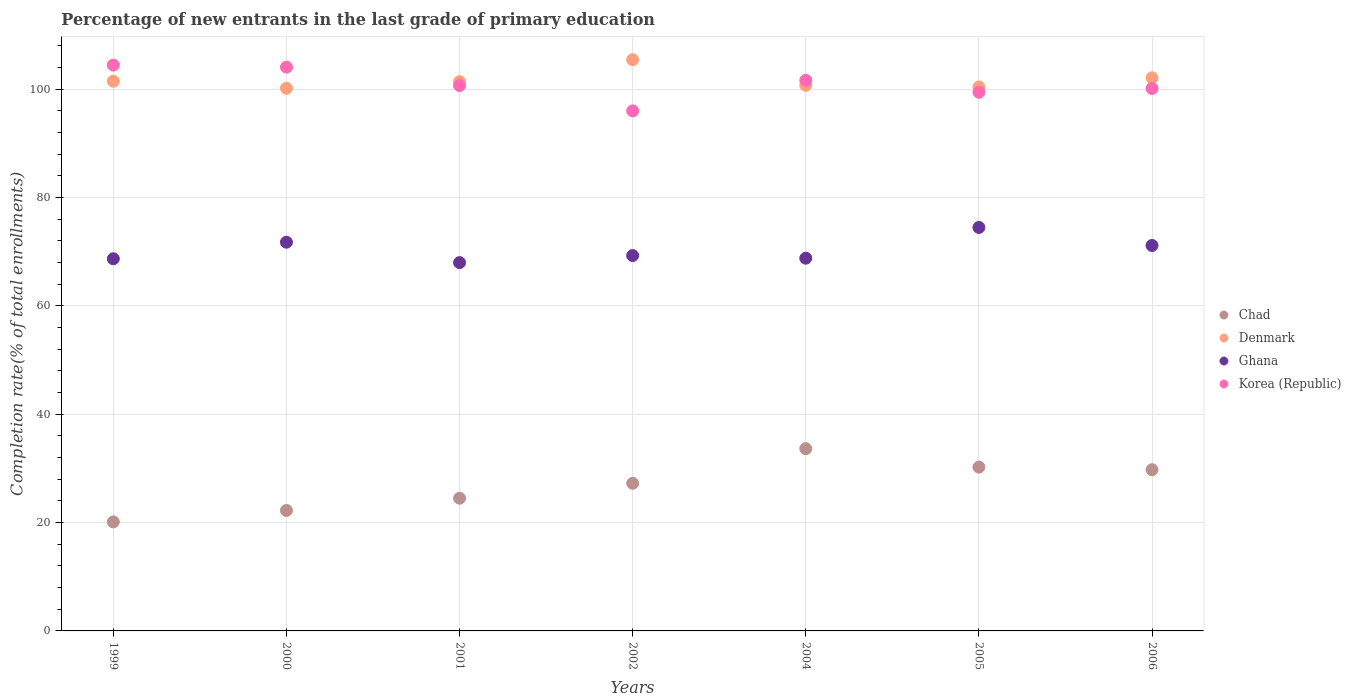How many different coloured dotlines are there?
Offer a very short reply. 4. What is the percentage of new entrants in Denmark in 2001?
Your response must be concise. 101.41. Across all years, what is the maximum percentage of new entrants in Ghana?
Keep it short and to the point. 74.5. Across all years, what is the minimum percentage of new entrants in Chad?
Keep it short and to the point. 20.13. What is the total percentage of new entrants in Korea (Republic) in the graph?
Make the answer very short. 706.56. What is the difference between the percentage of new entrants in Denmark in 2004 and that in 2006?
Make the answer very short. -1.38. What is the difference between the percentage of new entrants in Denmark in 2004 and the percentage of new entrants in Chad in 2005?
Ensure brevity in your answer.  70.51. What is the average percentage of new entrants in Chad per year?
Ensure brevity in your answer.  26.83. In the year 2004, what is the difference between the percentage of new entrants in Chad and percentage of new entrants in Korea (Republic)?
Give a very brief answer. -68.02. What is the ratio of the percentage of new entrants in Chad in 1999 to that in 2000?
Offer a terse response. 0.9. Is the percentage of new entrants in Chad in 1999 less than that in 2001?
Provide a succinct answer. Yes. What is the difference between the highest and the second highest percentage of new entrants in Korea (Republic)?
Offer a very short reply. 0.38. What is the difference between the highest and the lowest percentage of new entrants in Chad?
Offer a terse response. 13.52. In how many years, is the percentage of new entrants in Ghana greater than the average percentage of new entrants in Ghana taken over all years?
Keep it short and to the point. 3. Is it the case that in every year, the sum of the percentage of new entrants in Chad and percentage of new entrants in Korea (Republic)  is greater than the percentage of new entrants in Denmark?
Make the answer very short. Yes. Does the percentage of new entrants in Ghana monotonically increase over the years?
Offer a terse response. No. Is the percentage of new entrants in Chad strictly greater than the percentage of new entrants in Ghana over the years?
Your answer should be compact. No. How many years are there in the graph?
Offer a very short reply. 7. Are the values on the major ticks of Y-axis written in scientific E-notation?
Your answer should be very brief. No. Does the graph contain grids?
Give a very brief answer. Yes. How are the legend labels stacked?
Give a very brief answer. Vertical. What is the title of the graph?
Offer a very short reply. Percentage of new entrants in the last grade of primary education. Does "Italy" appear as one of the legend labels in the graph?
Provide a short and direct response. No. What is the label or title of the Y-axis?
Make the answer very short. Completion rate(% of total enrollments). What is the Completion rate(% of total enrollments) in Chad in 1999?
Make the answer very short. 20.13. What is the Completion rate(% of total enrollments) in Denmark in 1999?
Your response must be concise. 101.49. What is the Completion rate(% of total enrollments) in Ghana in 1999?
Ensure brevity in your answer.  68.71. What is the Completion rate(% of total enrollments) of Korea (Republic) in 1999?
Provide a short and direct response. 104.48. What is the Completion rate(% of total enrollments) of Chad in 2000?
Ensure brevity in your answer.  22.24. What is the Completion rate(% of total enrollments) in Denmark in 2000?
Provide a short and direct response. 100.19. What is the Completion rate(% of total enrollments) of Ghana in 2000?
Ensure brevity in your answer.  71.77. What is the Completion rate(% of total enrollments) of Korea (Republic) in 2000?
Provide a short and direct response. 104.1. What is the Completion rate(% of total enrollments) in Chad in 2001?
Ensure brevity in your answer.  24.5. What is the Completion rate(% of total enrollments) of Denmark in 2001?
Provide a short and direct response. 101.41. What is the Completion rate(% of total enrollments) in Ghana in 2001?
Keep it short and to the point. 68. What is the Completion rate(% of total enrollments) of Korea (Republic) in 2001?
Make the answer very short. 100.69. What is the Completion rate(% of total enrollments) of Chad in 2002?
Ensure brevity in your answer.  27.26. What is the Completion rate(% of total enrollments) in Denmark in 2002?
Offer a terse response. 105.47. What is the Completion rate(% of total enrollments) in Ghana in 2002?
Make the answer very short. 69.31. What is the Completion rate(% of total enrollments) of Korea (Republic) in 2002?
Provide a short and direct response. 96.02. What is the Completion rate(% of total enrollments) of Chad in 2004?
Offer a very short reply. 33.65. What is the Completion rate(% of total enrollments) of Denmark in 2004?
Your answer should be compact. 100.74. What is the Completion rate(% of total enrollments) of Ghana in 2004?
Give a very brief answer. 68.82. What is the Completion rate(% of total enrollments) in Korea (Republic) in 2004?
Your answer should be compact. 101.67. What is the Completion rate(% of total enrollments) in Chad in 2005?
Provide a short and direct response. 30.24. What is the Completion rate(% of total enrollments) of Denmark in 2005?
Your answer should be very brief. 100.45. What is the Completion rate(% of total enrollments) in Ghana in 2005?
Give a very brief answer. 74.5. What is the Completion rate(% of total enrollments) of Korea (Republic) in 2005?
Your answer should be very brief. 99.46. What is the Completion rate(% of total enrollments) of Chad in 2006?
Your answer should be very brief. 29.76. What is the Completion rate(% of total enrollments) in Denmark in 2006?
Ensure brevity in your answer.  102.13. What is the Completion rate(% of total enrollments) in Ghana in 2006?
Give a very brief answer. 71.17. What is the Completion rate(% of total enrollments) of Korea (Republic) in 2006?
Provide a short and direct response. 100.16. Across all years, what is the maximum Completion rate(% of total enrollments) of Chad?
Offer a very short reply. 33.65. Across all years, what is the maximum Completion rate(% of total enrollments) of Denmark?
Ensure brevity in your answer.  105.47. Across all years, what is the maximum Completion rate(% of total enrollments) of Ghana?
Your response must be concise. 74.5. Across all years, what is the maximum Completion rate(% of total enrollments) of Korea (Republic)?
Provide a succinct answer. 104.48. Across all years, what is the minimum Completion rate(% of total enrollments) of Chad?
Your answer should be very brief. 20.13. Across all years, what is the minimum Completion rate(% of total enrollments) of Denmark?
Your answer should be very brief. 100.19. Across all years, what is the minimum Completion rate(% of total enrollments) in Ghana?
Your answer should be very brief. 68. Across all years, what is the minimum Completion rate(% of total enrollments) of Korea (Republic)?
Your answer should be compact. 96.02. What is the total Completion rate(% of total enrollments) in Chad in the graph?
Provide a short and direct response. 187.79. What is the total Completion rate(% of total enrollments) of Denmark in the graph?
Your answer should be compact. 711.89. What is the total Completion rate(% of total enrollments) of Ghana in the graph?
Ensure brevity in your answer.  492.28. What is the total Completion rate(% of total enrollments) of Korea (Republic) in the graph?
Provide a succinct answer. 706.56. What is the difference between the Completion rate(% of total enrollments) in Chad in 1999 and that in 2000?
Offer a very short reply. -2.11. What is the difference between the Completion rate(% of total enrollments) of Denmark in 1999 and that in 2000?
Ensure brevity in your answer.  1.3. What is the difference between the Completion rate(% of total enrollments) of Ghana in 1999 and that in 2000?
Offer a very short reply. -3.06. What is the difference between the Completion rate(% of total enrollments) of Korea (Republic) in 1999 and that in 2000?
Provide a short and direct response. 0.38. What is the difference between the Completion rate(% of total enrollments) in Chad in 1999 and that in 2001?
Give a very brief answer. -4.37. What is the difference between the Completion rate(% of total enrollments) in Denmark in 1999 and that in 2001?
Offer a very short reply. 0.08. What is the difference between the Completion rate(% of total enrollments) in Ghana in 1999 and that in 2001?
Offer a terse response. 0.71. What is the difference between the Completion rate(% of total enrollments) of Korea (Republic) in 1999 and that in 2001?
Your answer should be compact. 3.79. What is the difference between the Completion rate(% of total enrollments) in Chad in 1999 and that in 2002?
Offer a very short reply. -7.13. What is the difference between the Completion rate(% of total enrollments) in Denmark in 1999 and that in 2002?
Offer a terse response. -3.98. What is the difference between the Completion rate(% of total enrollments) in Ghana in 1999 and that in 2002?
Your answer should be very brief. -0.6. What is the difference between the Completion rate(% of total enrollments) of Korea (Republic) in 1999 and that in 2002?
Keep it short and to the point. 8.45. What is the difference between the Completion rate(% of total enrollments) of Chad in 1999 and that in 2004?
Provide a short and direct response. -13.52. What is the difference between the Completion rate(% of total enrollments) in Denmark in 1999 and that in 2004?
Your answer should be very brief. 0.75. What is the difference between the Completion rate(% of total enrollments) of Ghana in 1999 and that in 2004?
Keep it short and to the point. -0.11. What is the difference between the Completion rate(% of total enrollments) of Korea (Republic) in 1999 and that in 2004?
Offer a very short reply. 2.81. What is the difference between the Completion rate(% of total enrollments) of Chad in 1999 and that in 2005?
Offer a terse response. -10.11. What is the difference between the Completion rate(% of total enrollments) in Denmark in 1999 and that in 2005?
Ensure brevity in your answer.  1.05. What is the difference between the Completion rate(% of total enrollments) in Ghana in 1999 and that in 2005?
Keep it short and to the point. -5.78. What is the difference between the Completion rate(% of total enrollments) of Korea (Republic) in 1999 and that in 2005?
Ensure brevity in your answer.  5.02. What is the difference between the Completion rate(% of total enrollments) in Chad in 1999 and that in 2006?
Offer a terse response. -9.63. What is the difference between the Completion rate(% of total enrollments) of Denmark in 1999 and that in 2006?
Provide a succinct answer. -0.63. What is the difference between the Completion rate(% of total enrollments) in Ghana in 1999 and that in 2006?
Give a very brief answer. -2.46. What is the difference between the Completion rate(% of total enrollments) in Korea (Republic) in 1999 and that in 2006?
Your response must be concise. 4.32. What is the difference between the Completion rate(% of total enrollments) of Chad in 2000 and that in 2001?
Ensure brevity in your answer.  -2.26. What is the difference between the Completion rate(% of total enrollments) in Denmark in 2000 and that in 2001?
Offer a terse response. -1.22. What is the difference between the Completion rate(% of total enrollments) of Ghana in 2000 and that in 2001?
Provide a succinct answer. 3.77. What is the difference between the Completion rate(% of total enrollments) of Korea (Republic) in 2000 and that in 2001?
Offer a terse response. 3.41. What is the difference between the Completion rate(% of total enrollments) of Chad in 2000 and that in 2002?
Offer a very short reply. -5.02. What is the difference between the Completion rate(% of total enrollments) of Denmark in 2000 and that in 2002?
Your answer should be very brief. -5.28. What is the difference between the Completion rate(% of total enrollments) in Ghana in 2000 and that in 2002?
Make the answer very short. 2.46. What is the difference between the Completion rate(% of total enrollments) in Korea (Republic) in 2000 and that in 2002?
Your answer should be compact. 8.07. What is the difference between the Completion rate(% of total enrollments) in Chad in 2000 and that in 2004?
Your response must be concise. -11.4. What is the difference between the Completion rate(% of total enrollments) in Denmark in 2000 and that in 2004?
Provide a short and direct response. -0.55. What is the difference between the Completion rate(% of total enrollments) in Ghana in 2000 and that in 2004?
Offer a very short reply. 2.95. What is the difference between the Completion rate(% of total enrollments) of Korea (Republic) in 2000 and that in 2004?
Give a very brief answer. 2.43. What is the difference between the Completion rate(% of total enrollments) of Chad in 2000 and that in 2005?
Make the answer very short. -7.99. What is the difference between the Completion rate(% of total enrollments) of Denmark in 2000 and that in 2005?
Keep it short and to the point. -0.25. What is the difference between the Completion rate(% of total enrollments) in Ghana in 2000 and that in 2005?
Provide a succinct answer. -2.72. What is the difference between the Completion rate(% of total enrollments) in Korea (Republic) in 2000 and that in 2005?
Offer a terse response. 4.64. What is the difference between the Completion rate(% of total enrollments) in Chad in 2000 and that in 2006?
Offer a very short reply. -7.52. What is the difference between the Completion rate(% of total enrollments) in Denmark in 2000 and that in 2006?
Ensure brevity in your answer.  -1.93. What is the difference between the Completion rate(% of total enrollments) of Ghana in 2000 and that in 2006?
Make the answer very short. 0.6. What is the difference between the Completion rate(% of total enrollments) of Korea (Republic) in 2000 and that in 2006?
Provide a short and direct response. 3.94. What is the difference between the Completion rate(% of total enrollments) in Chad in 2001 and that in 2002?
Your answer should be very brief. -2.76. What is the difference between the Completion rate(% of total enrollments) of Denmark in 2001 and that in 2002?
Make the answer very short. -4.06. What is the difference between the Completion rate(% of total enrollments) in Ghana in 2001 and that in 2002?
Make the answer very short. -1.31. What is the difference between the Completion rate(% of total enrollments) of Korea (Republic) in 2001 and that in 2002?
Provide a succinct answer. 4.67. What is the difference between the Completion rate(% of total enrollments) in Chad in 2001 and that in 2004?
Make the answer very short. -9.14. What is the difference between the Completion rate(% of total enrollments) of Denmark in 2001 and that in 2004?
Give a very brief answer. 0.67. What is the difference between the Completion rate(% of total enrollments) in Ghana in 2001 and that in 2004?
Your answer should be very brief. -0.82. What is the difference between the Completion rate(% of total enrollments) of Korea (Republic) in 2001 and that in 2004?
Give a very brief answer. -0.98. What is the difference between the Completion rate(% of total enrollments) in Chad in 2001 and that in 2005?
Provide a short and direct response. -5.73. What is the difference between the Completion rate(% of total enrollments) of Denmark in 2001 and that in 2005?
Your response must be concise. 0.97. What is the difference between the Completion rate(% of total enrollments) of Ghana in 2001 and that in 2005?
Offer a terse response. -6.49. What is the difference between the Completion rate(% of total enrollments) in Korea (Republic) in 2001 and that in 2005?
Your response must be concise. 1.23. What is the difference between the Completion rate(% of total enrollments) of Chad in 2001 and that in 2006?
Provide a short and direct response. -5.26. What is the difference between the Completion rate(% of total enrollments) of Denmark in 2001 and that in 2006?
Provide a short and direct response. -0.71. What is the difference between the Completion rate(% of total enrollments) of Ghana in 2001 and that in 2006?
Keep it short and to the point. -3.17. What is the difference between the Completion rate(% of total enrollments) of Korea (Republic) in 2001 and that in 2006?
Provide a succinct answer. 0.53. What is the difference between the Completion rate(% of total enrollments) in Chad in 2002 and that in 2004?
Provide a succinct answer. -6.38. What is the difference between the Completion rate(% of total enrollments) in Denmark in 2002 and that in 2004?
Offer a terse response. 4.73. What is the difference between the Completion rate(% of total enrollments) in Ghana in 2002 and that in 2004?
Provide a short and direct response. 0.49. What is the difference between the Completion rate(% of total enrollments) in Korea (Republic) in 2002 and that in 2004?
Provide a succinct answer. -5.64. What is the difference between the Completion rate(% of total enrollments) of Chad in 2002 and that in 2005?
Offer a very short reply. -2.97. What is the difference between the Completion rate(% of total enrollments) in Denmark in 2002 and that in 2005?
Your answer should be compact. 5.02. What is the difference between the Completion rate(% of total enrollments) of Ghana in 2002 and that in 2005?
Give a very brief answer. -5.19. What is the difference between the Completion rate(% of total enrollments) of Korea (Republic) in 2002 and that in 2005?
Offer a terse response. -3.43. What is the difference between the Completion rate(% of total enrollments) of Chad in 2002 and that in 2006?
Make the answer very short. -2.5. What is the difference between the Completion rate(% of total enrollments) of Denmark in 2002 and that in 2006?
Make the answer very short. 3.35. What is the difference between the Completion rate(% of total enrollments) in Ghana in 2002 and that in 2006?
Offer a terse response. -1.86. What is the difference between the Completion rate(% of total enrollments) in Korea (Republic) in 2002 and that in 2006?
Your answer should be very brief. -4.14. What is the difference between the Completion rate(% of total enrollments) in Chad in 2004 and that in 2005?
Offer a terse response. 3.41. What is the difference between the Completion rate(% of total enrollments) of Denmark in 2004 and that in 2005?
Make the answer very short. 0.29. What is the difference between the Completion rate(% of total enrollments) in Ghana in 2004 and that in 2005?
Provide a succinct answer. -5.68. What is the difference between the Completion rate(% of total enrollments) in Korea (Republic) in 2004 and that in 2005?
Your response must be concise. 2.21. What is the difference between the Completion rate(% of total enrollments) of Chad in 2004 and that in 2006?
Provide a succinct answer. 3.89. What is the difference between the Completion rate(% of total enrollments) in Denmark in 2004 and that in 2006?
Make the answer very short. -1.38. What is the difference between the Completion rate(% of total enrollments) of Ghana in 2004 and that in 2006?
Provide a short and direct response. -2.35. What is the difference between the Completion rate(% of total enrollments) of Korea (Republic) in 2004 and that in 2006?
Provide a succinct answer. 1.51. What is the difference between the Completion rate(% of total enrollments) in Chad in 2005 and that in 2006?
Keep it short and to the point. 0.47. What is the difference between the Completion rate(% of total enrollments) of Denmark in 2005 and that in 2006?
Your answer should be very brief. -1.68. What is the difference between the Completion rate(% of total enrollments) of Ghana in 2005 and that in 2006?
Offer a terse response. 3.33. What is the difference between the Completion rate(% of total enrollments) in Korea (Republic) in 2005 and that in 2006?
Provide a short and direct response. -0.7. What is the difference between the Completion rate(% of total enrollments) of Chad in 1999 and the Completion rate(% of total enrollments) of Denmark in 2000?
Make the answer very short. -80.06. What is the difference between the Completion rate(% of total enrollments) in Chad in 1999 and the Completion rate(% of total enrollments) in Ghana in 2000?
Provide a succinct answer. -51.64. What is the difference between the Completion rate(% of total enrollments) in Chad in 1999 and the Completion rate(% of total enrollments) in Korea (Republic) in 2000?
Your response must be concise. -83.97. What is the difference between the Completion rate(% of total enrollments) of Denmark in 1999 and the Completion rate(% of total enrollments) of Ghana in 2000?
Provide a short and direct response. 29.72. What is the difference between the Completion rate(% of total enrollments) in Denmark in 1999 and the Completion rate(% of total enrollments) in Korea (Republic) in 2000?
Give a very brief answer. -2.6. What is the difference between the Completion rate(% of total enrollments) in Ghana in 1999 and the Completion rate(% of total enrollments) in Korea (Republic) in 2000?
Provide a succinct answer. -35.38. What is the difference between the Completion rate(% of total enrollments) in Chad in 1999 and the Completion rate(% of total enrollments) in Denmark in 2001?
Keep it short and to the point. -81.28. What is the difference between the Completion rate(% of total enrollments) in Chad in 1999 and the Completion rate(% of total enrollments) in Ghana in 2001?
Offer a terse response. -47.87. What is the difference between the Completion rate(% of total enrollments) of Chad in 1999 and the Completion rate(% of total enrollments) of Korea (Republic) in 2001?
Ensure brevity in your answer.  -80.56. What is the difference between the Completion rate(% of total enrollments) of Denmark in 1999 and the Completion rate(% of total enrollments) of Ghana in 2001?
Offer a terse response. 33.49. What is the difference between the Completion rate(% of total enrollments) of Denmark in 1999 and the Completion rate(% of total enrollments) of Korea (Republic) in 2001?
Give a very brief answer. 0.8. What is the difference between the Completion rate(% of total enrollments) of Ghana in 1999 and the Completion rate(% of total enrollments) of Korea (Republic) in 2001?
Make the answer very short. -31.98. What is the difference between the Completion rate(% of total enrollments) of Chad in 1999 and the Completion rate(% of total enrollments) of Denmark in 2002?
Provide a short and direct response. -85.34. What is the difference between the Completion rate(% of total enrollments) in Chad in 1999 and the Completion rate(% of total enrollments) in Ghana in 2002?
Offer a terse response. -49.18. What is the difference between the Completion rate(% of total enrollments) of Chad in 1999 and the Completion rate(% of total enrollments) of Korea (Republic) in 2002?
Keep it short and to the point. -75.89. What is the difference between the Completion rate(% of total enrollments) of Denmark in 1999 and the Completion rate(% of total enrollments) of Ghana in 2002?
Your answer should be compact. 32.18. What is the difference between the Completion rate(% of total enrollments) of Denmark in 1999 and the Completion rate(% of total enrollments) of Korea (Republic) in 2002?
Make the answer very short. 5.47. What is the difference between the Completion rate(% of total enrollments) of Ghana in 1999 and the Completion rate(% of total enrollments) of Korea (Republic) in 2002?
Make the answer very short. -27.31. What is the difference between the Completion rate(% of total enrollments) in Chad in 1999 and the Completion rate(% of total enrollments) in Denmark in 2004?
Ensure brevity in your answer.  -80.61. What is the difference between the Completion rate(% of total enrollments) of Chad in 1999 and the Completion rate(% of total enrollments) of Ghana in 2004?
Your response must be concise. -48.69. What is the difference between the Completion rate(% of total enrollments) in Chad in 1999 and the Completion rate(% of total enrollments) in Korea (Republic) in 2004?
Provide a succinct answer. -81.54. What is the difference between the Completion rate(% of total enrollments) of Denmark in 1999 and the Completion rate(% of total enrollments) of Ghana in 2004?
Give a very brief answer. 32.67. What is the difference between the Completion rate(% of total enrollments) in Denmark in 1999 and the Completion rate(% of total enrollments) in Korea (Republic) in 2004?
Ensure brevity in your answer.  -0.17. What is the difference between the Completion rate(% of total enrollments) of Ghana in 1999 and the Completion rate(% of total enrollments) of Korea (Republic) in 2004?
Keep it short and to the point. -32.95. What is the difference between the Completion rate(% of total enrollments) in Chad in 1999 and the Completion rate(% of total enrollments) in Denmark in 2005?
Your answer should be compact. -80.32. What is the difference between the Completion rate(% of total enrollments) of Chad in 1999 and the Completion rate(% of total enrollments) of Ghana in 2005?
Offer a terse response. -54.37. What is the difference between the Completion rate(% of total enrollments) in Chad in 1999 and the Completion rate(% of total enrollments) in Korea (Republic) in 2005?
Your answer should be very brief. -79.33. What is the difference between the Completion rate(% of total enrollments) of Denmark in 1999 and the Completion rate(% of total enrollments) of Ghana in 2005?
Offer a terse response. 27. What is the difference between the Completion rate(% of total enrollments) in Denmark in 1999 and the Completion rate(% of total enrollments) in Korea (Republic) in 2005?
Give a very brief answer. 2.04. What is the difference between the Completion rate(% of total enrollments) of Ghana in 1999 and the Completion rate(% of total enrollments) of Korea (Republic) in 2005?
Provide a short and direct response. -30.74. What is the difference between the Completion rate(% of total enrollments) of Chad in 1999 and the Completion rate(% of total enrollments) of Denmark in 2006?
Your response must be concise. -82. What is the difference between the Completion rate(% of total enrollments) of Chad in 1999 and the Completion rate(% of total enrollments) of Ghana in 2006?
Provide a short and direct response. -51.04. What is the difference between the Completion rate(% of total enrollments) in Chad in 1999 and the Completion rate(% of total enrollments) in Korea (Republic) in 2006?
Ensure brevity in your answer.  -80.03. What is the difference between the Completion rate(% of total enrollments) in Denmark in 1999 and the Completion rate(% of total enrollments) in Ghana in 2006?
Provide a succinct answer. 30.33. What is the difference between the Completion rate(% of total enrollments) of Denmark in 1999 and the Completion rate(% of total enrollments) of Korea (Republic) in 2006?
Make the answer very short. 1.34. What is the difference between the Completion rate(% of total enrollments) in Ghana in 1999 and the Completion rate(% of total enrollments) in Korea (Republic) in 2006?
Offer a very short reply. -31.44. What is the difference between the Completion rate(% of total enrollments) in Chad in 2000 and the Completion rate(% of total enrollments) in Denmark in 2001?
Provide a succinct answer. -79.17. What is the difference between the Completion rate(% of total enrollments) in Chad in 2000 and the Completion rate(% of total enrollments) in Ghana in 2001?
Ensure brevity in your answer.  -45.76. What is the difference between the Completion rate(% of total enrollments) of Chad in 2000 and the Completion rate(% of total enrollments) of Korea (Republic) in 2001?
Ensure brevity in your answer.  -78.44. What is the difference between the Completion rate(% of total enrollments) of Denmark in 2000 and the Completion rate(% of total enrollments) of Ghana in 2001?
Your answer should be compact. 32.19. What is the difference between the Completion rate(% of total enrollments) in Denmark in 2000 and the Completion rate(% of total enrollments) in Korea (Republic) in 2001?
Your answer should be very brief. -0.49. What is the difference between the Completion rate(% of total enrollments) in Ghana in 2000 and the Completion rate(% of total enrollments) in Korea (Republic) in 2001?
Ensure brevity in your answer.  -28.92. What is the difference between the Completion rate(% of total enrollments) in Chad in 2000 and the Completion rate(% of total enrollments) in Denmark in 2002?
Give a very brief answer. -83.23. What is the difference between the Completion rate(% of total enrollments) of Chad in 2000 and the Completion rate(% of total enrollments) of Ghana in 2002?
Make the answer very short. -47.07. What is the difference between the Completion rate(% of total enrollments) of Chad in 2000 and the Completion rate(% of total enrollments) of Korea (Republic) in 2002?
Provide a succinct answer. -73.78. What is the difference between the Completion rate(% of total enrollments) in Denmark in 2000 and the Completion rate(% of total enrollments) in Ghana in 2002?
Offer a very short reply. 30.88. What is the difference between the Completion rate(% of total enrollments) in Denmark in 2000 and the Completion rate(% of total enrollments) in Korea (Republic) in 2002?
Offer a terse response. 4.17. What is the difference between the Completion rate(% of total enrollments) in Ghana in 2000 and the Completion rate(% of total enrollments) in Korea (Republic) in 2002?
Your answer should be compact. -24.25. What is the difference between the Completion rate(% of total enrollments) in Chad in 2000 and the Completion rate(% of total enrollments) in Denmark in 2004?
Keep it short and to the point. -78.5. What is the difference between the Completion rate(% of total enrollments) of Chad in 2000 and the Completion rate(% of total enrollments) of Ghana in 2004?
Your answer should be compact. -46.57. What is the difference between the Completion rate(% of total enrollments) of Chad in 2000 and the Completion rate(% of total enrollments) of Korea (Republic) in 2004?
Your answer should be very brief. -79.42. What is the difference between the Completion rate(% of total enrollments) of Denmark in 2000 and the Completion rate(% of total enrollments) of Ghana in 2004?
Keep it short and to the point. 31.37. What is the difference between the Completion rate(% of total enrollments) in Denmark in 2000 and the Completion rate(% of total enrollments) in Korea (Republic) in 2004?
Make the answer very short. -1.47. What is the difference between the Completion rate(% of total enrollments) in Ghana in 2000 and the Completion rate(% of total enrollments) in Korea (Republic) in 2004?
Make the answer very short. -29.89. What is the difference between the Completion rate(% of total enrollments) in Chad in 2000 and the Completion rate(% of total enrollments) in Denmark in 2005?
Provide a succinct answer. -78.2. What is the difference between the Completion rate(% of total enrollments) of Chad in 2000 and the Completion rate(% of total enrollments) of Ghana in 2005?
Keep it short and to the point. -52.25. What is the difference between the Completion rate(% of total enrollments) of Chad in 2000 and the Completion rate(% of total enrollments) of Korea (Republic) in 2005?
Provide a short and direct response. -77.21. What is the difference between the Completion rate(% of total enrollments) in Denmark in 2000 and the Completion rate(% of total enrollments) in Ghana in 2005?
Your answer should be very brief. 25.7. What is the difference between the Completion rate(% of total enrollments) in Denmark in 2000 and the Completion rate(% of total enrollments) in Korea (Republic) in 2005?
Provide a short and direct response. 0.74. What is the difference between the Completion rate(% of total enrollments) of Ghana in 2000 and the Completion rate(% of total enrollments) of Korea (Republic) in 2005?
Your answer should be compact. -27.68. What is the difference between the Completion rate(% of total enrollments) of Chad in 2000 and the Completion rate(% of total enrollments) of Denmark in 2006?
Your answer should be compact. -79.88. What is the difference between the Completion rate(% of total enrollments) in Chad in 2000 and the Completion rate(% of total enrollments) in Ghana in 2006?
Your response must be concise. -48.92. What is the difference between the Completion rate(% of total enrollments) of Chad in 2000 and the Completion rate(% of total enrollments) of Korea (Republic) in 2006?
Ensure brevity in your answer.  -77.91. What is the difference between the Completion rate(% of total enrollments) of Denmark in 2000 and the Completion rate(% of total enrollments) of Ghana in 2006?
Your response must be concise. 29.03. What is the difference between the Completion rate(% of total enrollments) of Denmark in 2000 and the Completion rate(% of total enrollments) of Korea (Republic) in 2006?
Your response must be concise. 0.04. What is the difference between the Completion rate(% of total enrollments) of Ghana in 2000 and the Completion rate(% of total enrollments) of Korea (Republic) in 2006?
Your answer should be compact. -28.38. What is the difference between the Completion rate(% of total enrollments) of Chad in 2001 and the Completion rate(% of total enrollments) of Denmark in 2002?
Provide a succinct answer. -80.97. What is the difference between the Completion rate(% of total enrollments) of Chad in 2001 and the Completion rate(% of total enrollments) of Ghana in 2002?
Ensure brevity in your answer.  -44.81. What is the difference between the Completion rate(% of total enrollments) of Chad in 2001 and the Completion rate(% of total enrollments) of Korea (Republic) in 2002?
Make the answer very short. -71.52. What is the difference between the Completion rate(% of total enrollments) of Denmark in 2001 and the Completion rate(% of total enrollments) of Ghana in 2002?
Offer a terse response. 32.1. What is the difference between the Completion rate(% of total enrollments) of Denmark in 2001 and the Completion rate(% of total enrollments) of Korea (Republic) in 2002?
Offer a very short reply. 5.39. What is the difference between the Completion rate(% of total enrollments) in Ghana in 2001 and the Completion rate(% of total enrollments) in Korea (Republic) in 2002?
Offer a terse response. -28.02. What is the difference between the Completion rate(% of total enrollments) in Chad in 2001 and the Completion rate(% of total enrollments) in Denmark in 2004?
Make the answer very short. -76.24. What is the difference between the Completion rate(% of total enrollments) in Chad in 2001 and the Completion rate(% of total enrollments) in Ghana in 2004?
Ensure brevity in your answer.  -44.32. What is the difference between the Completion rate(% of total enrollments) in Chad in 2001 and the Completion rate(% of total enrollments) in Korea (Republic) in 2004?
Offer a very short reply. -77.16. What is the difference between the Completion rate(% of total enrollments) in Denmark in 2001 and the Completion rate(% of total enrollments) in Ghana in 2004?
Offer a very short reply. 32.59. What is the difference between the Completion rate(% of total enrollments) of Denmark in 2001 and the Completion rate(% of total enrollments) of Korea (Republic) in 2004?
Your answer should be compact. -0.25. What is the difference between the Completion rate(% of total enrollments) of Ghana in 2001 and the Completion rate(% of total enrollments) of Korea (Republic) in 2004?
Keep it short and to the point. -33.66. What is the difference between the Completion rate(% of total enrollments) in Chad in 2001 and the Completion rate(% of total enrollments) in Denmark in 2005?
Make the answer very short. -75.95. What is the difference between the Completion rate(% of total enrollments) of Chad in 2001 and the Completion rate(% of total enrollments) of Ghana in 2005?
Your answer should be very brief. -49.99. What is the difference between the Completion rate(% of total enrollments) in Chad in 2001 and the Completion rate(% of total enrollments) in Korea (Republic) in 2005?
Make the answer very short. -74.95. What is the difference between the Completion rate(% of total enrollments) of Denmark in 2001 and the Completion rate(% of total enrollments) of Ghana in 2005?
Your answer should be very brief. 26.92. What is the difference between the Completion rate(% of total enrollments) of Denmark in 2001 and the Completion rate(% of total enrollments) of Korea (Republic) in 2005?
Give a very brief answer. 1.96. What is the difference between the Completion rate(% of total enrollments) in Ghana in 2001 and the Completion rate(% of total enrollments) in Korea (Republic) in 2005?
Give a very brief answer. -31.45. What is the difference between the Completion rate(% of total enrollments) of Chad in 2001 and the Completion rate(% of total enrollments) of Denmark in 2006?
Your response must be concise. -77.62. What is the difference between the Completion rate(% of total enrollments) in Chad in 2001 and the Completion rate(% of total enrollments) in Ghana in 2006?
Make the answer very short. -46.67. What is the difference between the Completion rate(% of total enrollments) in Chad in 2001 and the Completion rate(% of total enrollments) in Korea (Republic) in 2006?
Make the answer very short. -75.65. What is the difference between the Completion rate(% of total enrollments) in Denmark in 2001 and the Completion rate(% of total enrollments) in Ghana in 2006?
Your response must be concise. 30.25. What is the difference between the Completion rate(% of total enrollments) of Denmark in 2001 and the Completion rate(% of total enrollments) of Korea (Republic) in 2006?
Your answer should be very brief. 1.26. What is the difference between the Completion rate(% of total enrollments) of Ghana in 2001 and the Completion rate(% of total enrollments) of Korea (Republic) in 2006?
Provide a succinct answer. -32.16. What is the difference between the Completion rate(% of total enrollments) in Chad in 2002 and the Completion rate(% of total enrollments) in Denmark in 2004?
Provide a short and direct response. -73.48. What is the difference between the Completion rate(% of total enrollments) of Chad in 2002 and the Completion rate(% of total enrollments) of Ghana in 2004?
Provide a short and direct response. -41.56. What is the difference between the Completion rate(% of total enrollments) of Chad in 2002 and the Completion rate(% of total enrollments) of Korea (Republic) in 2004?
Your answer should be compact. -74.4. What is the difference between the Completion rate(% of total enrollments) of Denmark in 2002 and the Completion rate(% of total enrollments) of Ghana in 2004?
Your response must be concise. 36.65. What is the difference between the Completion rate(% of total enrollments) of Denmark in 2002 and the Completion rate(% of total enrollments) of Korea (Republic) in 2004?
Provide a succinct answer. 3.81. What is the difference between the Completion rate(% of total enrollments) of Ghana in 2002 and the Completion rate(% of total enrollments) of Korea (Republic) in 2004?
Give a very brief answer. -32.35. What is the difference between the Completion rate(% of total enrollments) in Chad in 2002 and the Completion rate(% of total enrollments) in Denmark in 2005?
Offer a very short reply. -73.19. What is the difference between the Completion rate(% of total enrollments) in Chad in 2002 and the Completion rate(% of total enrollments) in Ghana in 2005?
Give a very brief answer. -47.23. What is the difference between the Completion rate(% of total enrollments) in Chad in 2002 and the Completion rate(% of total enrollments) in Korea (Republic) in 2005?
Offer a very short reply. -72.19. What is the difference between the Completion rate(% of total enrollments) in Denmark in 2002 and the Completion rate(% of total enrollments) in Ghana in 2005?
Ensure brevity in your answer.  30.98. What is the difference between the Completion rate(% of total enrollments) in Denmark in 2002 and the Completion rate(% of total enrollments) in Korea (Republic) in 2005?
Your answer should be very brief. 6.02. What is the difference between the Completion rate(% of total enrollments) in Ghana in 2002 and the Completion rate(% of total enrollments) in Korea (Republic) in 2005?
Make the answer very short. -30.15. What is the difference between the Completion rate(% of total enrollments) of Chad in 2002 and the Completion rate(% of total enrollments) of Denmark in 2006?
Offer a terse response. -74.86. What is the difference between the Completion rate(% of total enrollments) of Chad in 2002 and the Completion rate(% of total enrollments) of Ghana in 2006?
Your answer should be compact. -43.91. What is the difference between the Completion rate(% of total enrollments) in Chad in 2002 and the Completion rate(% of total enrollments) in Korea (Republic) in 2006?
Provide a succinct answer. -72.89. What is the difference between the Completion rate(% of total enrollments) in Denmark in 2002 and the Completion rate(% of total enrollments) in Ghana in 2006?
Offer a terse response. 34.3. What is the difference between the Completion rate(% of total enrollments) of Denmark in 2002 and the Completion rate(% of total enrollments) of Korea (Republic) in 2006?
Offer a terse response. 5.32. What is the difference between the Completion rate(% of total enrollments) of Ghana in 2002 and the Completion rate(% of total enrollments) of Korea (Republic) in 2006?
Your answer should be compact. -30.85. What is the difference between the Completion rate(% of total enrollments) of Chad in 2004 and the Completion rate(% of total enrollments) of Denmark in 2005?
Make the answer very short. -66.8. What is the difference between the Completion rate(% of total enrollments) of Chad in 2004 and the Completion rate(% of total enrollments) of Ghana in 2005?
Your response must be concise. -40.85. What is the difference between the Completion rate(% of total enrollments) in Chad in 2004 and the Completion rate(% of total enrollments) in Korea (Republic) in 2005?
Make the answer very short. -65.81. What is the difference between the Completion rate(% of total enrollments) of Denmark in 2004 and the Completion rate(% of total enrollments) of Ghana in 2005?
Provide a short and direct response. 26.25. What is the difference between the Completion rate(% of total enrollments) of Denmark in 2004 and the Completion rate(% of total enrollments) of Korea (Republic) in 2005?
Keep it short and to the point. 1.29. What is the difference between the Completion rate(% of total enrollments) of Ghana in 2004 and the Completion rate(% of total enrollments) of Korea (Republic) in 2005?
Keep it short and to the point. -30.64. What is the difference between the Completion rate(% of total enrollments) of Chad in 2004 and the Completion rate(% of total enrollments) of Denmark in 2006?
Your response must be concise. -68.48. What is the difference between the Completion rate(% of total enrollments) of Chad in 2004 and the Completion rate(% of total enrollments) of Ghana in 2006?
Offer a terse response. -37.52. What is the difference between the Completion rate(% of total enrollments) of Chad in 2004 and the Completion rate(% of total enrollments) of Korea (Republic) in 2006?
Give a very brief answer. -66.51. What is the difference between the Completion rate(% of total enrollments) of Denmark in 2004 and the Completion rate(% of total enrollments) of Ghana in 2006?
Make the answer very short. 29.57. What is the difference between the Completion rate(% of total enrollments) of Denmark in 2004 and the Completion rate(% of total enrollments) of Korea (Republic) in 2006?
Your answer should be compact. 0.58. What is the difference between the Completion rate(% of total enrollments) of Ghana in 2004 and the Completion rate(% of total enrollments) of Korea (Republic) in 2006?
Offer a terse response. -31.34. What is the difference between the Completion rate(% of total enrollments) in Chad in 2005 and the Completion rate(% of total enrollments) in Denmark in 2006?
Make the answer very short. -71.89. What is the difference between the Completion rate(% of total enrollments) in Chad in 2005 and the Completion rate(% of total enrollments) in Ghana in 2006?
Offer a terse response. -40.93. What is the difference between the Completion rate(% of total enrollments) of Chad in 2005 and the Completion rate(% of total enrollments) of Korea (Republic) in 2006?
Your response must be concise. -69.92. What is the difference between the Completion rate(% of total enrollments) in Denmark in 2005 and the Completion rate(% of total enrollments) in Ghana in 2006?
Keep it short and to the point. 29.28. What is the difference between the Completion rate(% of total enrollments) of Denmark in 2005 and the Completion rate(% of total enrollments) of Korea (Republic) in 2006?
Give a very brief answer. 0.29. What is the difference between the Completion rate(% of total enrollments) of Ghana in 2005 and the Completion rate(% of total enrollments) of Korea (Republic) in 2006?
Give a very brief answer. -25.66. What is the average Completion rate(% of total enrollments) of Chad per year?
Your answer should be very brief. 26.83. What is the average Completion rate(% of total enrollments) of Denmark per year?
Keep it short and to the point. 101.7. What is the average Completion rate(% of total enrollments) of Ghana per year?
Offer a very short reply. 70.33. What is the average Completion rate(% of total enrollments) in Korea (Republic) per year?
Keep it short and to the point. 100.94. In the year 1999, what is the difference between the Completion rate(% of total enrollments) in Chad and Completion rate(% of total enrollments) in Denmark?
Offer a very short reply. -81.36. In the year 1999, what is the difference between the Completion rate(% of total enrollments) in Chad and Completion rate(% of total enrollments) in Ghana?
Offer a very short reply. -48.58. In the year 1999, what is the difference between the Completion rate(% of total enrollments) in Chad and Completion rate(% of total enrollments) in Korea (Republic)?
Give a very brief answer. -84.35. In the year 1999, what is the difference between the Completion rate(% of total enrollments) in Denmark and Completion rate(% of total enrollments) in Ghana?
Your response must be concise. 32.78. In the year 1999, what is the difference between the Completion rate(% of total enrollments) in Denmark and Completion rate(% of total enrollments) in Korea (Republic)?
Keep it short and to the point. -2.98. In the year 1999, what is the difference between the Completion rate(% of total enrollments) of Ghana and Completion rate(% of total enrollments) of Korea (Republic)?
Your answer should be very brief. -35.76. In the year 2000, what is the difference between the Completion rate(% of total enrollments) in Chad and Completion rate(% of total enrollments) in Denmark?
Provide a succinct answer. -77.95. In the year 2000, what is the difference between the Completion rate(% of total enrollments) of Chad and Completion rate(% of total enrollments) of Ghana?
Offer a very short reply. -49.53. In the year 2000, what is the difference between the Completion rate(% of total enrollments) of Chad and Completion rate(% of total enrollments) of Korea (Republic)?
Keep it short and to the point. -81.85. In the year 2000, what is the difference between the Completion rate(% of total enrollments) in Denmark and Completion rate(% of total enrollments) in Ghana?
Provide a succinct answer. 28.42. In the year 2000, what is the difference between the Completion rate(% of total enrollments) of Denmark and Completion rate(% of total enrollments) of Korea (Republic)?
Your response must be concise. -3.9. In the year 2000, what is the difference between the Completion rate(% of total enrollments) of Ghana and Completion rate(% of total enrollments) of Korea (Republic)?
Keep it short and to the point. -32.32. In the year 2001, what is the difference between the Completion rate(% of total enrollments) in Chad and Completion rate(% of total enrollments) in Denmark?
Provide a succinct answer. -76.91. In the year 2001, what is the difference between the Completion rate(% of total enrollments) in Chad and Completion rate(% of total enrollments) in Ghana?
Your answer should be compact. -43.5. In the year 2001, what is the difference between the Completion rate(% of total enrollments) of Chad and Completion rate(% of total enrollments) of Korea (Republic)?
Your answer should be very brief. -76.19. In the year 2001, what is the difference between the Completion rate(% of total enrollments) in Denmark and Completion rate(% of total enrollments) in Ghana?
Give a very brief answer. 33.41. In the year 2001, what is the difference between the Completion rate(% of total enrollments) in Denmark and Completion rate(% of total enrollments) in Korea (Republic)?
Provide a succinct answer. 0.72. In the year 2001, what is the difference between the Completion rate(% of total enrollments) in Ghana and Completion rate(% of total enrollments) in Korea (Republic)?
Your response must be concise. -32.69. In the year 2002, what is the difference between the Completion rate(% of total enrollments) of Chad and Completion rate(% of total enrollments) of Denmark?
Provide a short and direct response. -78.21. In the year 2002, what is the difference between the Completion rate(% of total enrollments) in Chad and Completion rate(% of total enrollments) in Ghana?
Keep it short and to the point. -42.05. In the year 2002, what is the difference between the Completion rate(% of total enrollments) in Chad and Completion rate(% of total enrollments) in Korea (Republic)?
Offer a very short reply. -68.76. In the year 2002, what is the difference between the Completion rate(% of total enrollments) of Denmark and Completion rate(% of total enrollments) of Ghana?
Provide a short and direct response. 36.16. In the year 2002, what is the difference between the Completion rate(% of total enrollments) in Denmark and Completion rate(% of total enrollments) in Korea (Republic)?
Your response must be concise. 9.45. In the year 2002, what is the difference between the Completion rate(% of total enrollments) in Ghana and Completion rate(% of total enrollments) in Korea (Republic)?
Your response must be concise. -26.71. In the year 2004, what is the difference between the Completion rate(% of total enrollments) in Chad and Completion rate(% of total enrollments) in Denmark?
Provide a short and direct response. -67.09. In the year 2004, what is the difference between the Completion rate(% of total enrollments) of Chad and Completion rate(% of total enrollments) of Ghana?
Give a very brief answer. -35.17. In the year 2004, what is the difference between the Completion rate(% of total enrollments) of Chad and Completion rate(% of total enrollments) of Korea (Republic)?
Offer a terse response. -68.02. In the year 2004, what is the difference between the Completion rate(% of total enrollments) of Denmark and Completion rate(% of total enrollments) of Ghana?
Your answer should be very brief. 31.92. In the year 2004, what is the difference between the Completion rate(% of total enrollments) of Denmark and Completion rate(% of total enrollments) of Korea (Republic)?
Make the answer very short. -0.92. In the year 2004, what is the difference between the Completion rate(% of total enrollments) of Ghana and Completion rate(% of total enrollments) of Korea (Republic)?
Provide a succinct answer. -32.85. In the year 2005, what is the difference between the Completion rate(% of total enrollments) in Chad and Completion rate(% of total enrollments) in Denmark?
Your answer should be compact. -70.21. In the year 2005, what is the difference between the Completion rate(% of total enrollments) of Chad and Completion rate(% of total enrollments) of Ghana?
Your answer should be very brief. -44.26. In the year 2005, what is the difference between the Completion rate(% of total enrollments) of Chad and Completion rate(% of total enrollments) of Korea (Republic)?
Make the answer very short. -69.22. In the year 2005, what is the difference between the Completion rate(% of total enrollments) in Denmark and Completion rate(% of total enrollments) in Ghana?
Your answer should be compact. 25.95. In the year 2005, what is the difference between the Completion rate(% of total enrollments) in Ghana and Completion rate(% of total enrollments) in Korea (Republic)?
Offer a terse response. -24.96. In the year 2006, what is the difference between the Completion rate(% of total enrollments) in Chad and Completion rate(% of total enrollments) in Denmark?
Offer a terse response. -72.36. In the year 2006, what is the difference between the Completion rate(% of total enrollments) of Chad and Completion rate(% of total enrollments) of Ghana?
Offer a terse response. -41.41. In the year 2006, what is the difference between the Completion rate(% of total enrollments) in Chad and Completion rate(% of total enrollments) in Korea (Republic)?
Keep it short and to the point. -70.4. In the year 2006, what is the difference between the Completion rate(% of total enrollments) of Denmark and Completion rate(% of total enrollments) of Ghana?
Offer a terse response. 30.96. In the year 2006, what is the difference between the Completion rate(% of total enrollments) of Denmark and Completion rate(% of total enrollments) of Korea (Republic)?
Provide a short and direct response. 1.97. In the year 2006, what is the difference between the Completion rate(% of total enrollments) of Ghana and Completion rate(% of total enrollments) of Korea (Republic)?
Your answer should be very brief. -28.99. What is the ratio of the Completion rate(% of total enrollments) of Chad in 1999 to that in 2000?
Offer a terse response. 0.9. What is the ratio of the Completion rate(% of total enrollments) of Denmark in 1999 to that in 2000?
Ensure brevity in your answer.  1.01. What is the ratio of the Completion rate(% of total enrollments) of Ghana in 1999 to that in 2000?
Offer a terse response. 0.96. What is the ratio of the Completion rate(% of total enrollments) in Chad in 1999 to that in 2001?
Offer a very short reply. 0.82. What is the ratio of the Completion rate(% of total enrollments) in Denmark in 1999 to that in 2001?
Provide a short and direct response. 1. What is the ratio of the Completion rate(% of total enrollments) in Ghana in 1999 to that in 2001?
Offer a very short reply. 1.01. What is the ratio of the Completion rate(% of total enrollments) of Korea (Republic) in 1999 to that in 2001?
Offer a very short reply. 1.04. What is the ratio of the Completion rate(% of total enrollments) of Chad in 1999 to that in 2002?
Keep it short and to the point. 0.74. What is the ratio of the Completion rate(% of total enrollments) of Denmark in 1999 to that in 2002?
Provide a short and direct response. 0.96. What is the ratio of the Completion rate(% of total enrollments) of Ghana in 1999 to that in 2002?
Your answer should be very brief. 0.99. What is the ratio of the Completion rate(% of total enrollments) of Korea (Republic) in 1999 to that in 2002?
Your answer should be very brief. 1.09. What is the ratio of the Completion rate(% of total enrollments) of Chad in 1999 to that in 2004?
Make the answer very short. 0.6. What is the ratio of the Completion rate(% of total enrollments) in Denmark in 1999 to that in 2004?
Ensure brevity in your answer.  1.01. What is the ratio of the Completion rate(% of total enrollments) of Ghana in 1999 to that in 2004?
Ensure brevity in your answer.  1. What is the ratio of the Completion rate(% of total enrollments) of Korea (Republic) in 1999 to that in 2004?
Ensure brevity in your answer.  1.03. What is the ratio of the Completion rate(% of total enrollments) of Chad in 1999 to that in 2005?
Give a very brief answer. 0.67. What is the ratio of the Completion rate(% of total enrollments) of Denmark in 1999 to that in 2005?
Provide a succinct answer. 1.01. What is the ratio of the Completion rate(% of total enrollments) in Ghana in 1999 to that in 2005?
Your response must be concise. 0.92. What is the ratio of the Completion rate(% of total enrollments) of Korea (Republic) in 1999 to that in 2005?
Your response must be concise. 1.05. What is the ratio of the Completion rate(% of total enrollments) of Chad in 1999 to that in 2006?
Provide a succinct answer. 0.68. What is the ratio of the Completion rate(% of total enrollments) in Ghana in 1999 to that in 2006?
Keep it short and to the point. 0.97. What is the ratio of the Completion rate(% of total enrollments) in Korea (Republic) in 1999 to that in 2006?
Provide a succinct answer. 1.04. What is the ratio of the Completion rate(% of total enrollments) in Chad in 2000 to that in 2001?
Offer a very short reply. 0.91. What is the ratio of the Completion rate(% of total enrollments) of Denmark in 2000 to that in 2001?
Make the answer very short. 0.99. What is the ratio of the Completion rate(% of total enrollments) of Ghana in 2000 to that in 2001?
Ensure brevity in your answer.  1.06. What is the ratio of the Completion rate(% of total enrollments) in Korea (Republic) in 2000 to that in 2001?
Your answer should be very brief. 1.03. What is the ratio of the Completion rate(% of total enrollments) in Chad in 2000 to that in 2002?
Your answer should be compact. 0.82. What is the ratio of the Completion rate(% of total enrollments) of Ghana in 2000 to that in 2002?
Your answer should be compact. 1.04. What is the ratio of the Completion rate(% of total enrollments) in Korea (Republic) in 2000 to that in 2002?
Ensure brevity in your answer.  1.08. What is the ratio of the Completion rate(% of total enrollments) in Chad in 2000 to that in 2004?
Make the answer very short. 0.66. What is the ratio of the Completion rate(% of total enrollments) in Denmark in 2000 to that in 2004?
Keep it short and to the point. 0.99. What is the ratio of the Completion rate(% of total enrollments) of Ghana in 2000 to that in 2004?
Offer a very short reply. 1.04. What is the ratio of the Completion rate(% of total enrollments) of Korea (Republic) in 2000 to that in 2004?
Offer a very short reply. 1.02. What is the ratio of the Completion rate(% of total enrollments) in Chad in 2000 to that in 2005?
Keep it short and to the point. 0.74. What is the ratio of the Completion rate(% of total enrollments) of Ghana in 2000 to that in 2005?
Keep it short and to the point. 0.96. What is the ratio of the Completion rate(% of total enrollments) of Korea (Republic) in 2000 to that in 2005?
Your answer should be compact. 1.05. What is the ratio of the Completion rate(% of total enrollments) in Chad in 2000 to that in 2006?
Provide a succinct answer. 0.75. What is the ratio of the Completion rate(% of total enrollments) of Denmark in 2000 to that in 2006?
Provide a succinct answer. 0.98. What is the ratio of the Completion rate(% of total enrollments) in Ghana in 2000 to that in 2006?
Your response must be concise. 1.01. What is the ratio of the Completion rate(% of total enrollments) of Korea (Republic) in 2000 to that in 2006?
Your answer should be compact. 1.04. What is the ratio of the Completion rate(% of total enrollments) of Chad in 2001 to that in 2002?
Provide a succinct answer. 0.9. What is the ratio of the Completion rate(% of total enrollments) of Denmark in 2001 to that in 2002?
Provide a succinct answer. 0.96. What is the ratio of the Completion rate(% of total enrollments) in Ghana in 2001 to that in 2002?
Give a very brief answer. 0.98. What is the ratio of the Completion rate(% of total enrollments) of Korea (Republic) in 2001 to that in 2002?
Offer a terse response. 1.05. What is the ratio of the Completion rate(% of total enrollments) of Chad in 2001 to that in 2004?
Offer a terse response. 0.73. What is the ratio of the Completion rate(% of total enrollments) of Chad in 2001 to that in 2005?
Provide a succinct answer. 0.81. What is the ratio of the Completion rate(% of total enrollments) of Denmark in 2001 to that in 2005?
Your response must be concise. 1.01. What is the ratio of the Completion rate(% of total enrollments) in Ghana in 2001 to that in 2005?
Provide a short and direct response. 0.91. What is the ratio of the Completion rate(% of total enrollments) in Korea (Republic) in 2001 to that in 2005?
Your answer should be very brief. 1.01. What is the ratio of the Completion rate(% of total enrollments) of Chad in 2001 to that in 2006?
Offer a very short reply. 0.82. What is the ratio of the Completion rate(% of total enrollments) in Ghana in 2001 to that in 2006?
Ensure brevity in your answer.  0.96. What is the ratio of the Completion rate(% of total enrollments) of Chad in 2002 to that in 2004?
Your answer should be compact. 0.81. What is the ratio of the Completion rate(% of total enrollments) of Denmark in 2002 to that in 2004?
Keep it short and to the point. 1.05. What is the ratio of the Completion rate(% of total enrollments) in Ghana in 2002 to that in 2004?
Keep it short and to the point. 1.01. What is the ratio of the Completion rate(% of total enrollments) in Korea (Republic) in 2002 to that in 2004?
Your answer should be compact. 0.94. What is the ratio of the Completion rate(% of total enrollments) in Chad in 2002 to that in 2005?
Give a very brief answer. 0.9. What is the ratio of the Completion rate(% of total enrollments) in Denmark in 2002 to that in 2005?
Keep it short and to the point. 1.05. What is the ratio of the Completion rate(% of total enrollments) in Ghana in 2002 to that in 2005?
Keep it short and to the point. 0.93. What is the ratio of the Completion rate(% of total enrollments) of Korea (Republic) in 2002 to that in 2005?
Make the answer very short. 0.97. What is the ratio of the Completion rate(% of total enrollments) in Chad in 2002 to that in 2006?
Provide a succinct answer. 0.92. What is the ratio of the Completion rate(% of total enrollments) in Denmark in 2002 to that in 2006?
Your answer should be very brief. 1.03. What is the ratio of the Completion rate(% of total enrollments) of Ghana in 2002 to that in 2006?
Provide a succinct answer. 0.97. What is the ratio of the Completion rate(% of total enrollments) of Korea (Republic) in 2002 to that in 2006?
Offer a very short reply. 0.96. What is the ratio of the Completion rate(% of total enrollments) of Chad in 2004 to that in 2005?
Offer a terse response. 1.11. What is the ratio of the Completion rate(% of total enrollments) of Ghana in 2004 to that in 2005?
Offer a terse response. 0.92. What is the ratio of the Completion rate(% of total enrollments) of Korea (Republic) in 2004 to that in 2005?
Ensure brevity in your answer.  1.02. What is the ratio of the Completion rate(% of total enrollments) of Chad in 2004 to that in 2006?
Your answer should be very brief. 1.13. What is the ratio of the Completion rate(% of total enrollments) of Denmark in 2004 to that in 2006?
Your answer should be compact. 0.99. What is the ratio of the Completion rate(% of total enrollments) in Korea (Republic) in 2004 to that in 2006?
Offer a very short reply. 1.02. What is the ratio of the Completion rate(% of total enrollments) in Chad in 2005 to that in 2006?
Offer a very short reply. 1.02. What is the ratio of the Completion rate(% of total enrollments) of Denmark in 2005 to that in 2006?
Provide a succinct answer. 0.98. What is the ratio of the Completion rate(% of total enrollments) of Ghana in 2005 to that in 2006?
Offer a very short reply. 1.05. What is the difference between the highest and the second highest Completion rate(% of total enrollments) in Chad?
Make the answer very short. 3.41. What is the difference between the highest and the second highest Completion rate(% of total enrollments) in Denmark?
Offer a terse response. 3.35. What is the difference between the highest and the second highest Completion rate(% of total enrollments) of Ghana?
Offer a very short reply. 2.72. What is the difference between the highest and the second highest Completion rate(% of total enrollments) of Korea (Republic)?
Give a very brief answer. 0.38. What is the difference between the highest and the lowest Completion rate(% of total enrollments) of Chad?
Provide a short and direct response. 13.52. What is the difference between the highest and the lowest Completion rate(% of total enrollments) in Denmark?
Your answer should be very brief. 5.28. What is the difference between the highest and the lowest Completion rate(% of total enrollments) of Ghana?
Make the answer very short. 6.49. What is the difference between the highest and the lowest Completion rate(% of total enrollments) of Korea (Republic)?
Give a very brief answer. 8.45. 